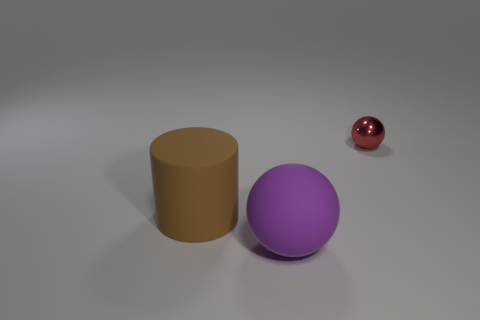Add 1 blue shiny blocks. How many objects exist? 4 Subtract all spheres. How many objects are left? 1 Add 3 large purple spheres. How many large purple spheres are left? 4 Add 3 small brown cylinders. How many small brown cylinders exist? 3 Subtract 0 green spheres. How many objects are left? 3 Subtract all big rubber balls. Subtract all big brown rubber cylinders. How many objects are left? 1 